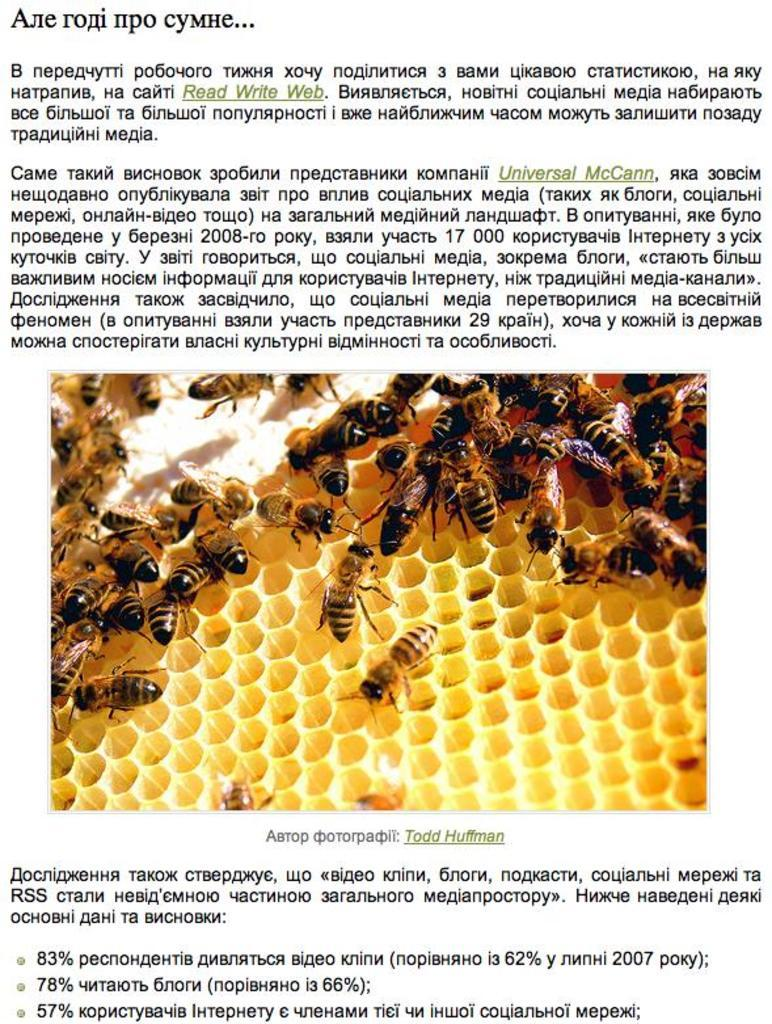What is the main subject of the image? The main subject of the image is a honeycomb. Are there any living creatures in the image? Yes, honeybees are present in the image. What else can be seen in the image besides the honeycomb and honeybees? There is text at the top and bottom of the image. Can you tell me how many friends the honeycomb has in the image? There is no mention of friends in the image; it features a honeycomb and honeybees. What part of the brain is responsible for processing the image of the honeycomb? The image does not provide information about the viewer's brain or its functions. 